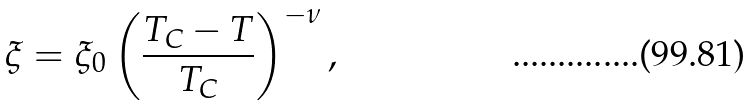<formula> <loc_0><loc_0><loc_500><loc_500>\xi = \xi _ { 0 } \left ( \frac { T _ { C } - T } { T _ { C } } \right ) ^ { - \nu } ,</formula> 